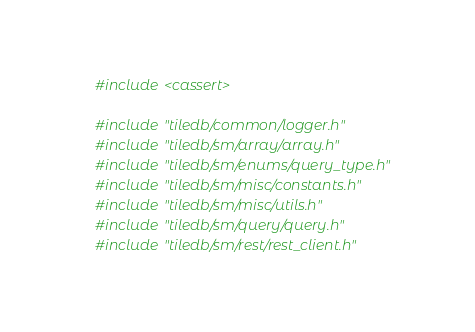Convert code to text. <code><loc_0><loc_0><loc_500><loc_500><_C++_>
#include <cassert>

#include "tiledb/common/logger.h"
#include "tiledb/sm/array/array.h"
#include "tiledb/sm/enums/query_type.h"
#include "tiledb/sm/misc/constants.h"
#include "tiledb/sm/misc/utils.h"
#include "tiledb/sm/query/query.h"
#include "tiledb/sm/rest/rest_client.h"</code> 